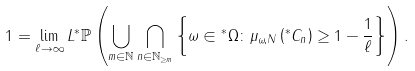Convert formula to latex. <formula><loc_0><loc_0><loc_500><loc_500>1 & = \lim _ { \ell \rightarrow \infty } L { ^ { * } } \mathbb { P } \left ( \bigcup _ { m \in \mathbb { N } } \bigcap _ { n \in \mathbb { N } _ { \geq m } } \left \{ \omega \in { ^ { * } } \Omega \colon \mu _ { \omega , N } \left ( { ^ { * } } C _ { n } \right ) \geq 1 - \frac { 1 } { \ell } \right \} \right ) .</formula> 